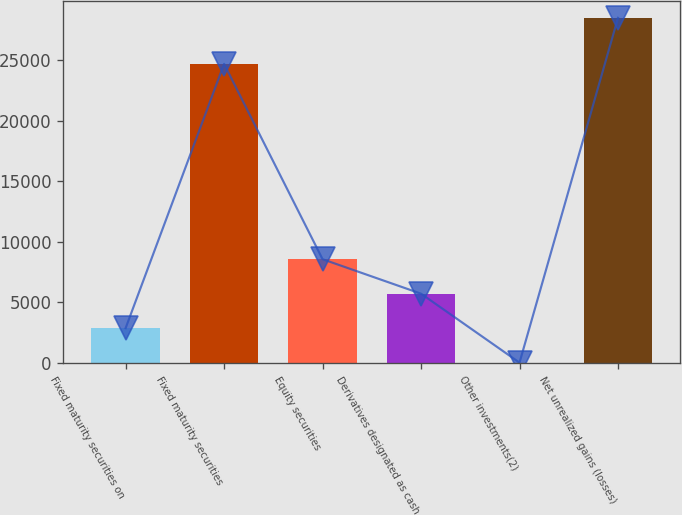Convert chart. <chart><loc_0><loc_0><loc_500><loc_500><bar_chart><fcel>Fixed maturity securities on<fcel>Fixed maturity securities<fcel>Equity securities<fcel>Derivatives designated as cash<fcel>Other investments(2)<fcel>Net unrealized gains (losses)<nl><fcel>2869.9<fcel>24673<fcel>8559.7<fcel>5714.8<fcel>25<fcel>28474<nl></chart> 